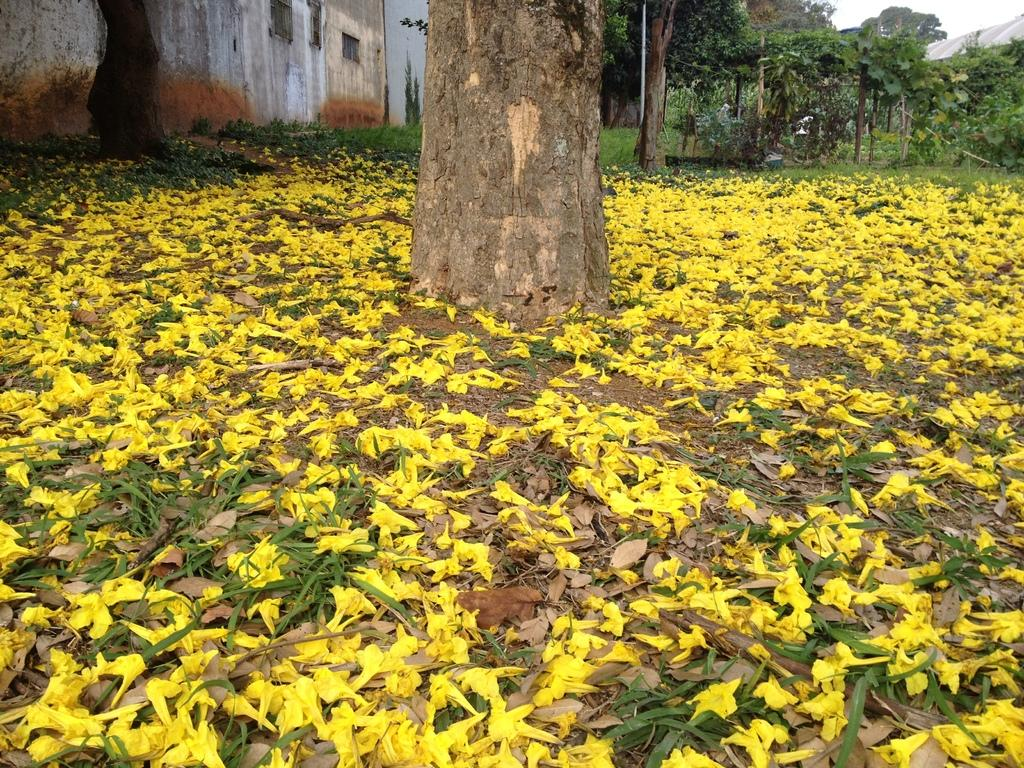What type of vegetation can be seen in the image? There are trees in the image. What type of structures are present in the image? There are buildings in the image. What is the purpose of the wall in the image? The wall in the image serves as a barrier or boundary. What type of flowers can be seen on the ground in the image? There are yellow color flowers on the ground in the image. Who is the manager of the level in the image? There is no reference to a manager or level in the image, as it features trees, buildings, a wall, and yellow flowers on the ground. 